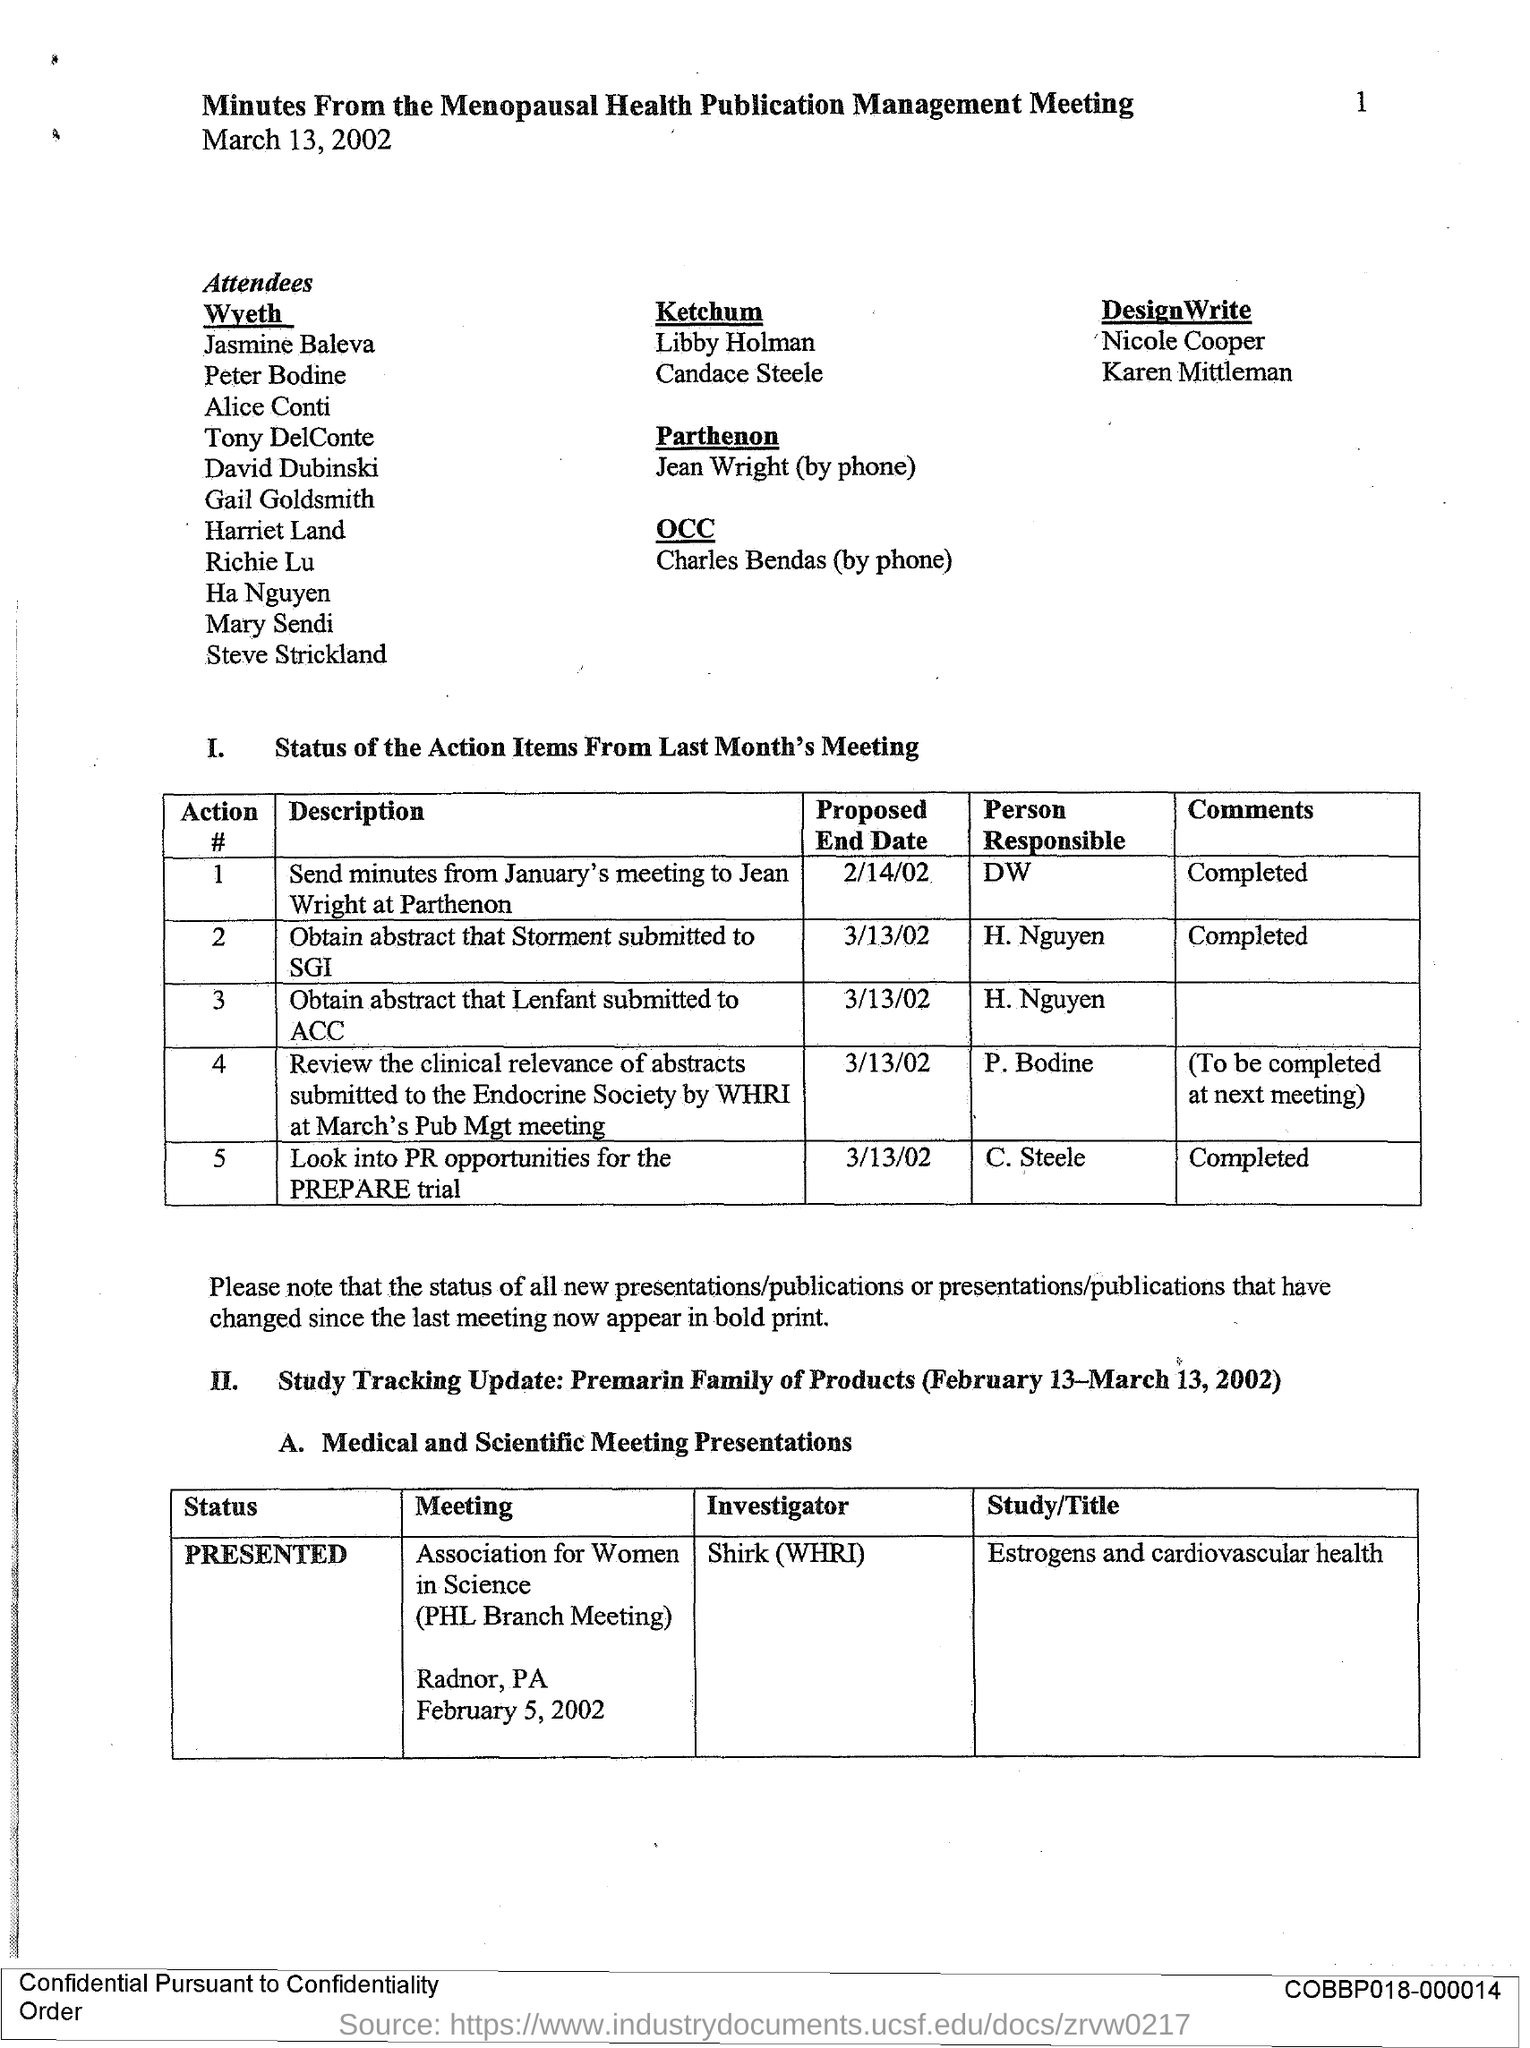Highlight a few significant elements in this photo. Parthenon will receive the minutes from the January meeting by February 14th, 2002. The person responsible for obtaining the abstract that Lenfant submitted to ACC is H. NGUYEN. The proposed end date to obtain the abstract that Storment submitted to SGI is March 13, 2002. The end date proposed by Lenfant for obtaining an abstract was March 13, 2002. The person responsible for obtaining the abstract that Storment submitted to SGI is H. Nguyen. 